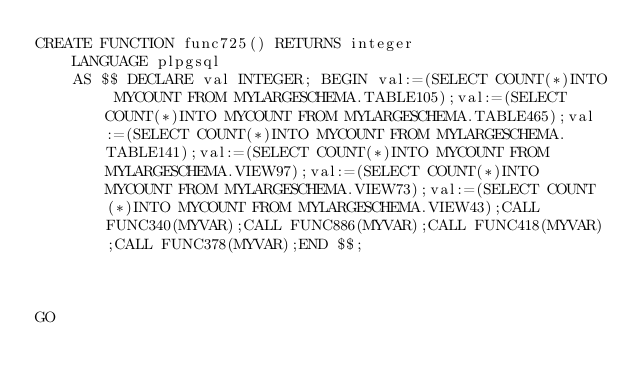Convert code to text. <code><loc_0><loc_0><loc_500><loc_500><_SQL_>CREATE FUNCTION func725() RETURNS integer
    LANGUAGE plpgsql
    AS $$ DECLARE val INTEGER; BEGIN val:=(SELECT COUNT(*)INTO MYCOUNT FROM MYLARGESCHEMA.TABLE105);val:=(SELECT COUNT(*)INTO MYCOUNT FROM MYLARGESCHEMA.TABLE465);val:=(SELECT COUNT(*)INTO MYCOUNT FROM MYLARGESCHEMA.TABLE141);val:=(SELECT COUNT(*)INTO MYCOUNT FROM MYLARGESCHEMA.VIEW97);val:=(SELECT COUNT(*)INTO MYCOUNT FROM MYLARGESCHEMA.VIEW73);val:=(SELECT COUNT(*)INTO MYCOUNT FROM MYLARGESCHEMA.VIEW43);CALL FUNC340(MYVAR);CALL FUNC886(MYVAR);CALL FUNC418(MYVAR);CALL FUNC378(MYVAR);END $$;



GO</code> 